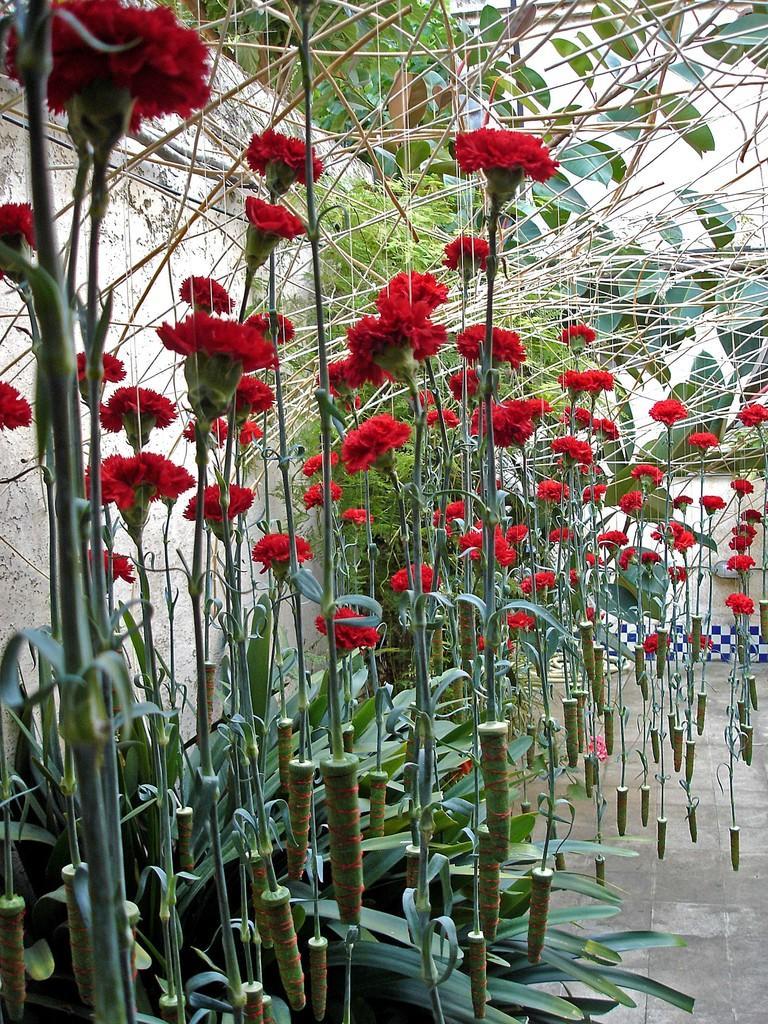In one or two sentences, can you explain what this image depicts? As we can see red flowers in the image and next to the flowers there is a wall and a tree. 